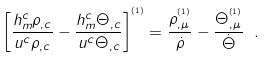Convert formula to latex. <formula><loc_0><loc_0><loc_500><loc_500>\left [ \frac { h ^ { c } _ { m } \rho _ { , c } } { u ^ { c } \rho _ { , c } } - \frac { h ^ { c } _ { m } \Theta _ { , c } } { u ^ { c } \Theta _ { , c } } \right ] ^ { ^ { \left ( 1 \right ) } } = \frac { \rho ^ { ^ { \left ( 1 \right ) } } _ { , \mu } } { \dot { \rho } } - \frac { \Theta ^ { ^ { \left ( 1 \right ) } } _ { , \mu } } { \dot { \Theta } } \ .</formula> 